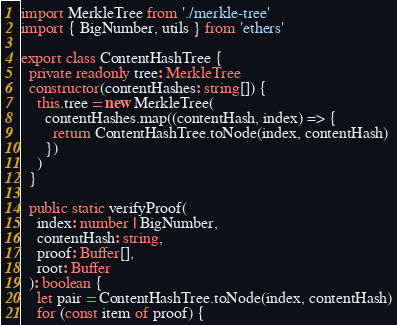Convert code to text. <code><loc_0><loc_0><loc_500><loc_500><_TypeScript_>import MerkleTree from './merkle-tree'
import { BigNumber, utils } from 'ethers'

export class ContentHashTree {
  private readonly tree: MerkleTree
  constructor(contentHashes: string[]) {
    this.tree = new MerkleTree(
      contentHashes.map((contentHash, index) => {
        return ContentHashTree.toNode(index, contentHash)
      })
    )
  }

  public static verifyProof(
    index: number | BigNumber,
    contentHash: string,
    proof: Buffer[],
    root: Buffer
  ): boolean {
    let pair = ContentHashTree.toNode(index, contentHash)
    for (const item of proof) {</code> 